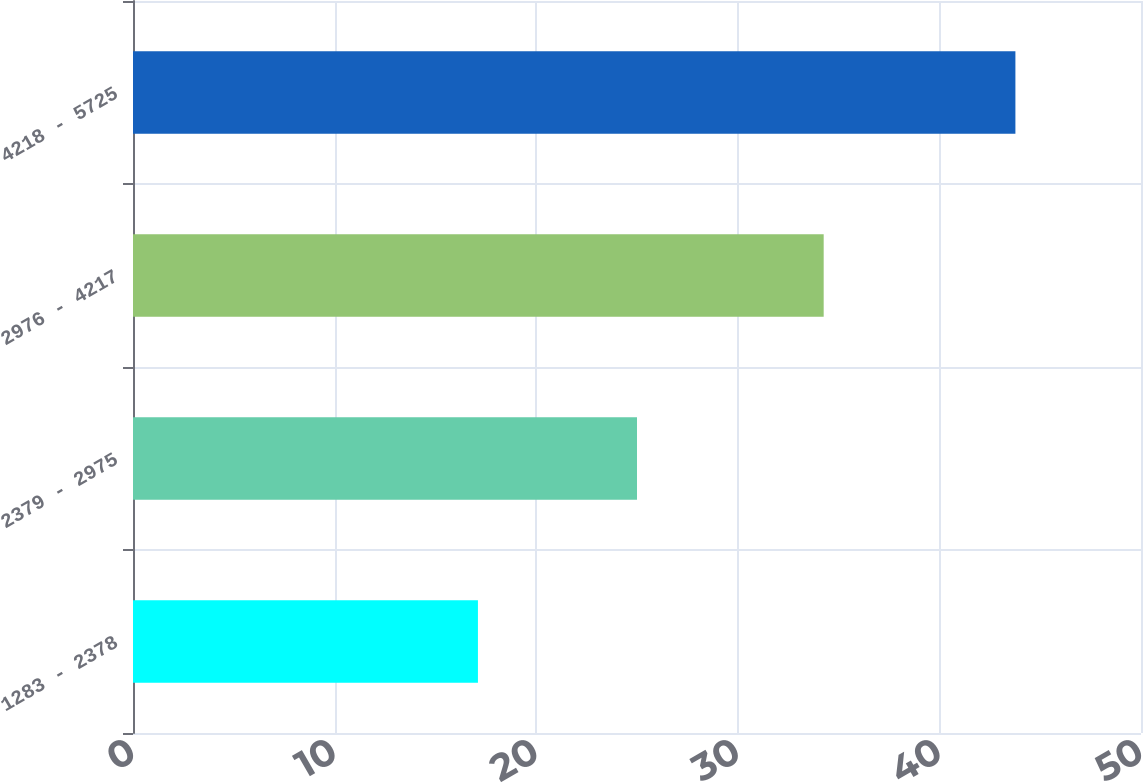Convert chart. <chart><loc_0><loc_0><loc_500><loc_500><bar_chart><fcel>1283 - 2378<fcel>2379 - 2975<fcel>2976 - 4217<fcel>4218 - 5725<nl><fcel>17.11<fcel>25<fcel>34.26<fcel>43.77<nl></chart> 